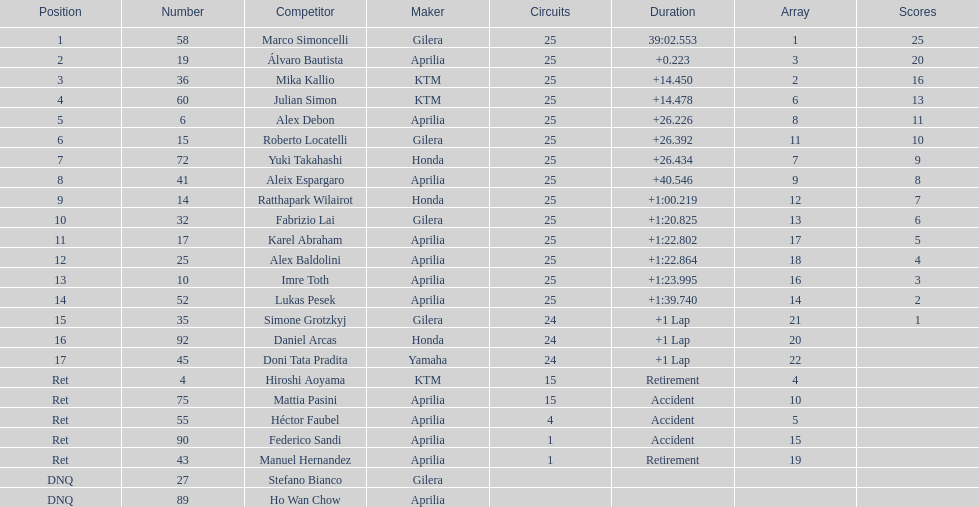What is the total number of rider? 24. 